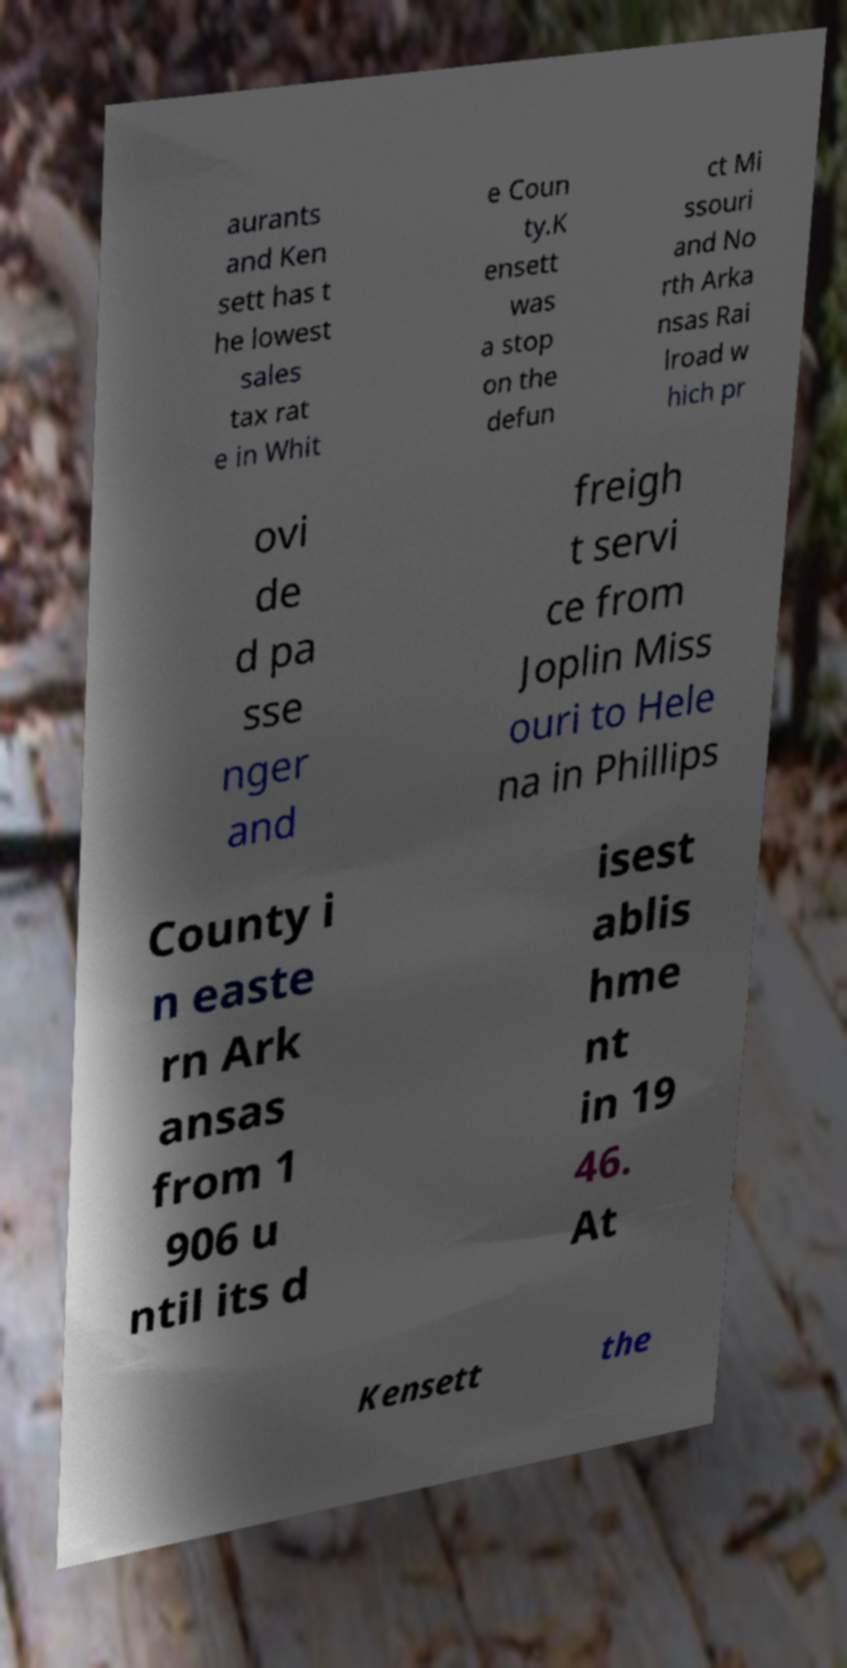What messages or text are displayed in this image? I need them in a readable, typed format. aurants and Ken sett has t he lowest sales tax rat e in Whit e Coun ty.K ensett was a stop on the defun ct Mi ssouri and No rth Arka nsas Rai lroad w hich pr ovi de d pa sse nger and freigh t servi ce from Joplin Miss ouri to Hele na in Phillips County i n easte rn Ark ansas from 1 906 u ntil its d isest ablis hme nt in 19 46. At Kensett the 